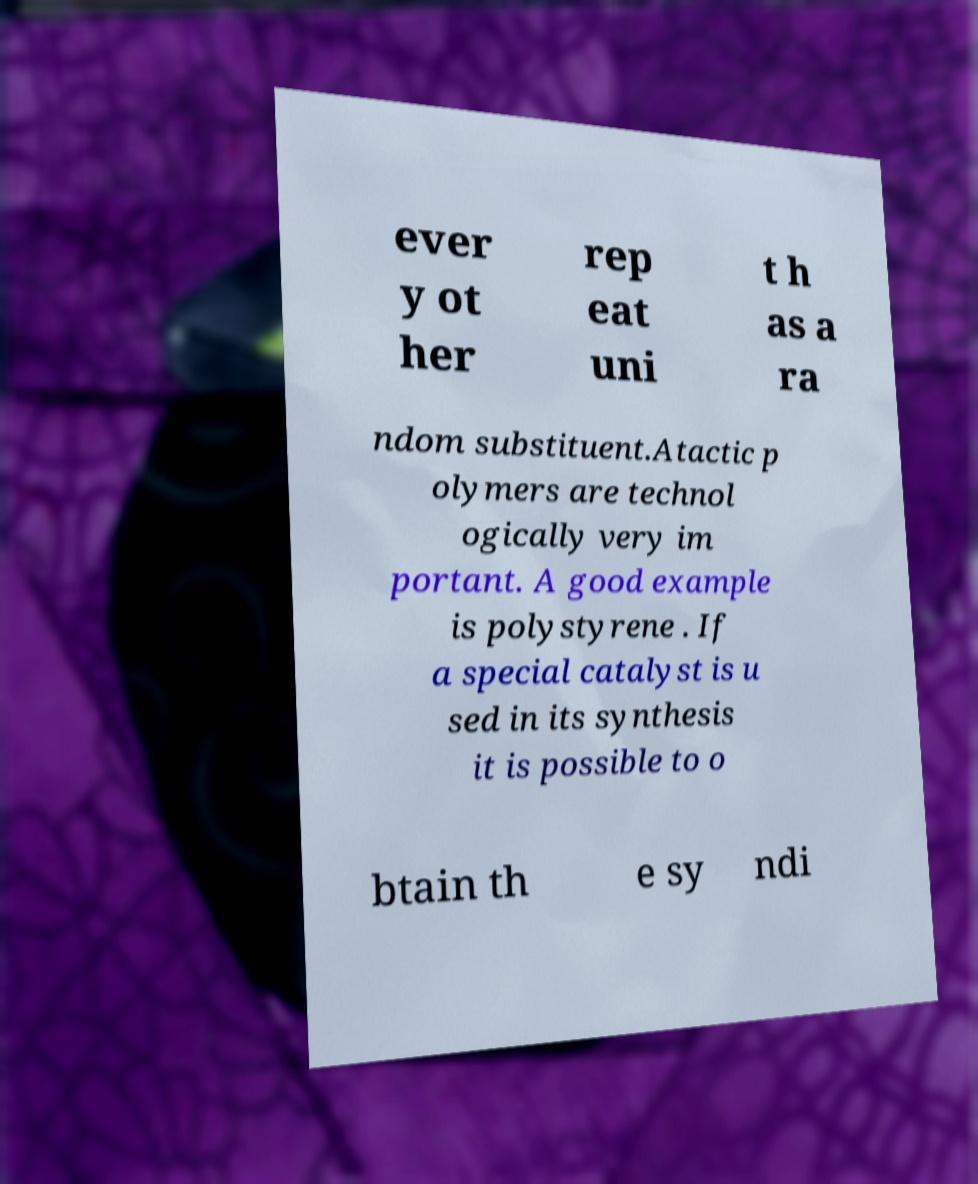Can you read and provide the text displayed in the image?This photo seems to have some interesting text. Can you extract and type it out for me? ever y ot her rep eat uni t h as a ra ndom substituent.Atactic p olymers are technol ogically very im portant. A good example is polystyrene . If a special catalyst is u sed in its synthesis it is possible to o btain th e sy ndi 